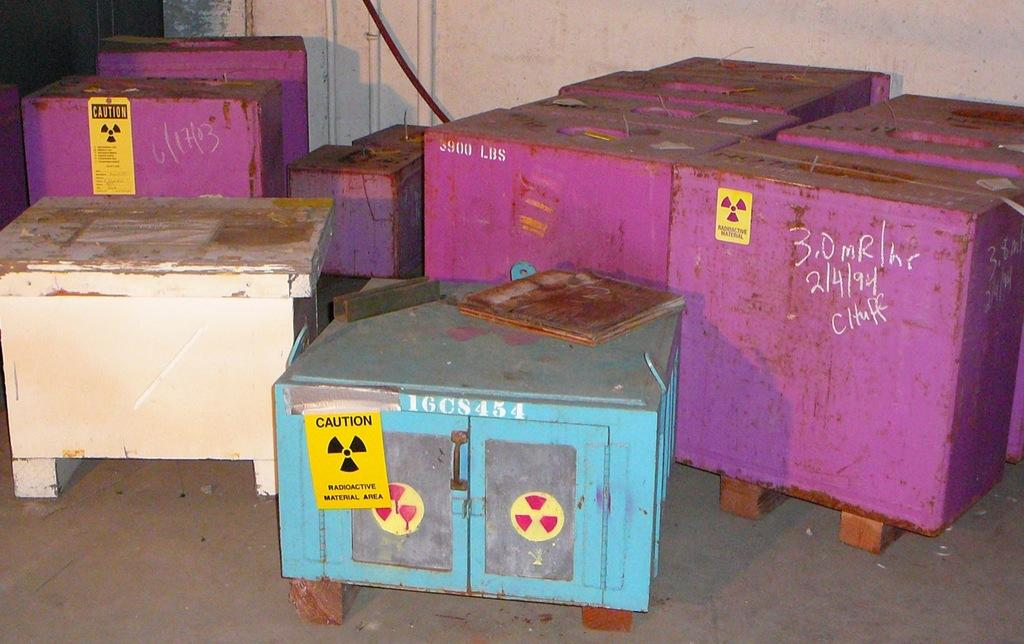<image>
Give a short and clear explanation of the subsequent image. Pink, white and blue containers of radioactive material are stored in a radioactive material area. 